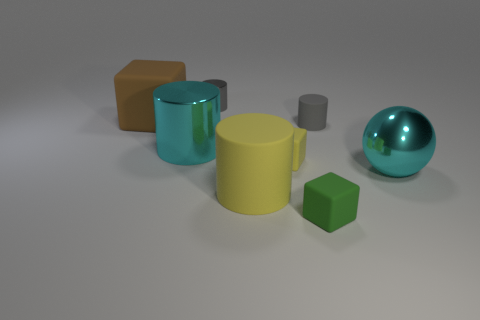What size is the thing that is both to the left of the tiny metal cylinder and behind the small gray matte thing?
Make the answer very short. Large. What number of big things have the same material as the cyan sphere?
Your answer should be very brief. 1. What number of blocks are small matte things or large cyan things?
Provide a short and direct response. 2. What size is the cyan metal thing on the right side of the big cylinder to the left of the rubber cylinder that is left of the green thing?
Ensure brevity in your answer.  Large. There is a object that is to the left of the small yellow cube and in front of the large shiny ball; what color is it?
Make the answer very short. Yellow. Does the yellow rubber cylinder have the same size as the cyan thing that is on the right side of the big yellow rubber thing?
Keep it short and to the point. Yes. There is a big rubber object that is the same shape as the tiny yellow thing; what color is it?
Your response must be concise. Brown. Do the brown matte cube and the green rubber block have the same size?
Your answer should be very brief. No. How many other things are the same size as the yellow cube?
Your answer should be compact. 3. How many things are large cyan things right of the cyan cylinder or matte cubes behind the large cyan metallic ball?
Your answer should be very brief. 3. 